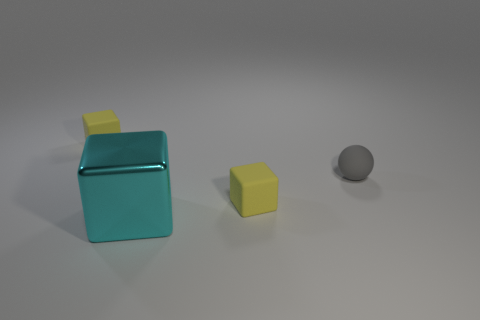Is there anything else that has the same material as the large cyan thing?
Your answer should be very brief. No. Is the number of gray spheres that are in front of the cyan shiny block the same as the number of gray matte balls that are behind the ball?
Your answer should be compact. Yes. Is the size of the cyan shiny object the same as the rubber object left of the cyan block?
Make the answer very short. No. Are there any large cyan objects that are right of the tiny rubber sphere right of the large cyan metal block?
Provide a succinct answer. No. Are there any small gray metal objects that have the same shape as the cyan metallic thing?
Give a very brief answer. No. There is a yellow rubber cube that is in front of the small cube that is behind the small gray rubber sphere; how many rubber objects are to the right of it?
Make the answer very short. 1. Is the color of the matte ball the same as the small object on the left side of the large block?
Make the answer very short. No. How many objects are either tiny matte objects that are to the right of the cyan cube or tiny matte things on the left side of the cyan shiny object?
Offer a very short reply. 3. Are there more gray things behind the ball than yellow cubes on the right side of the large thing?
Your answer should be very brief. No. The small cube behind the tiny yellow matte block that is in front of the tiny yellow block behind the gray object is made of what material?
Your answer should be compact. Rubber. 